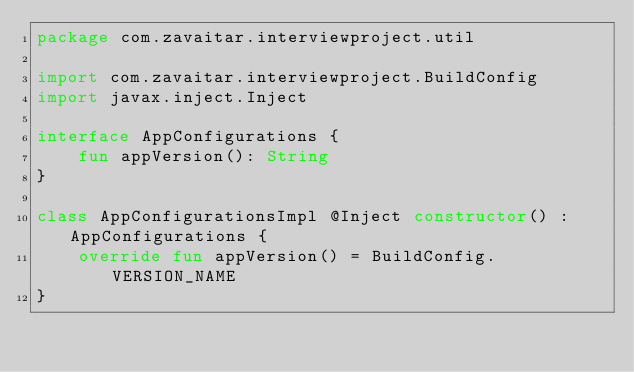<code> <loc_0><loc_0><loc_500><loc_500><_Kotlin_>package com.zavaitar.interviewproject.util

import com.zavaitar.interviewproject.BuildConfig
import javax.inject.Inject

interface AppConfigurations {
    fun appVersion(): String
}

class AppConfigurationsImpl @Inject constructor() : AppConfigurations {
    override fun appVersion() = BuildConfig.VERSION_NAME
}
</code> 